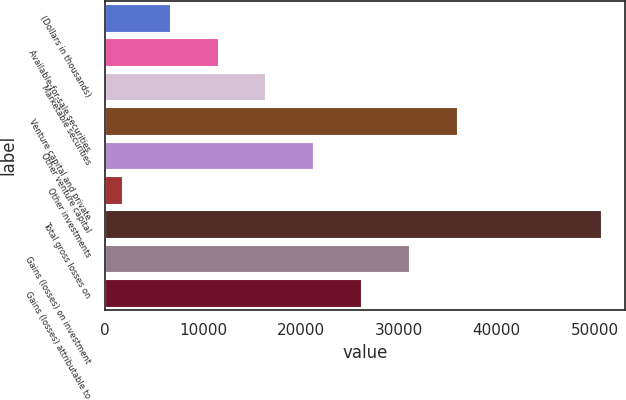Convert chart. <chart><loc_0><loc_0><loc_500><loc_500><bar_chart><fcel>(Dollars in thousands)<fcel>Available-for-sale securities<fcel>Marketable securities<fcel>Venture capital and private<fcel>Other venture capital<fcel>Other investments<fcel>Total gross losses on<fcel>Gains (losses) on investment<fcel>Gains (losses) attributable to<nl><fcel>6577.1<fcel>11469.2<fcel>16361.3<fcel>35929.7<fcel>21253.4<fcel>1685<fcel>50606<fcel>31037.6<fcel>26145.5<nl></chart> 